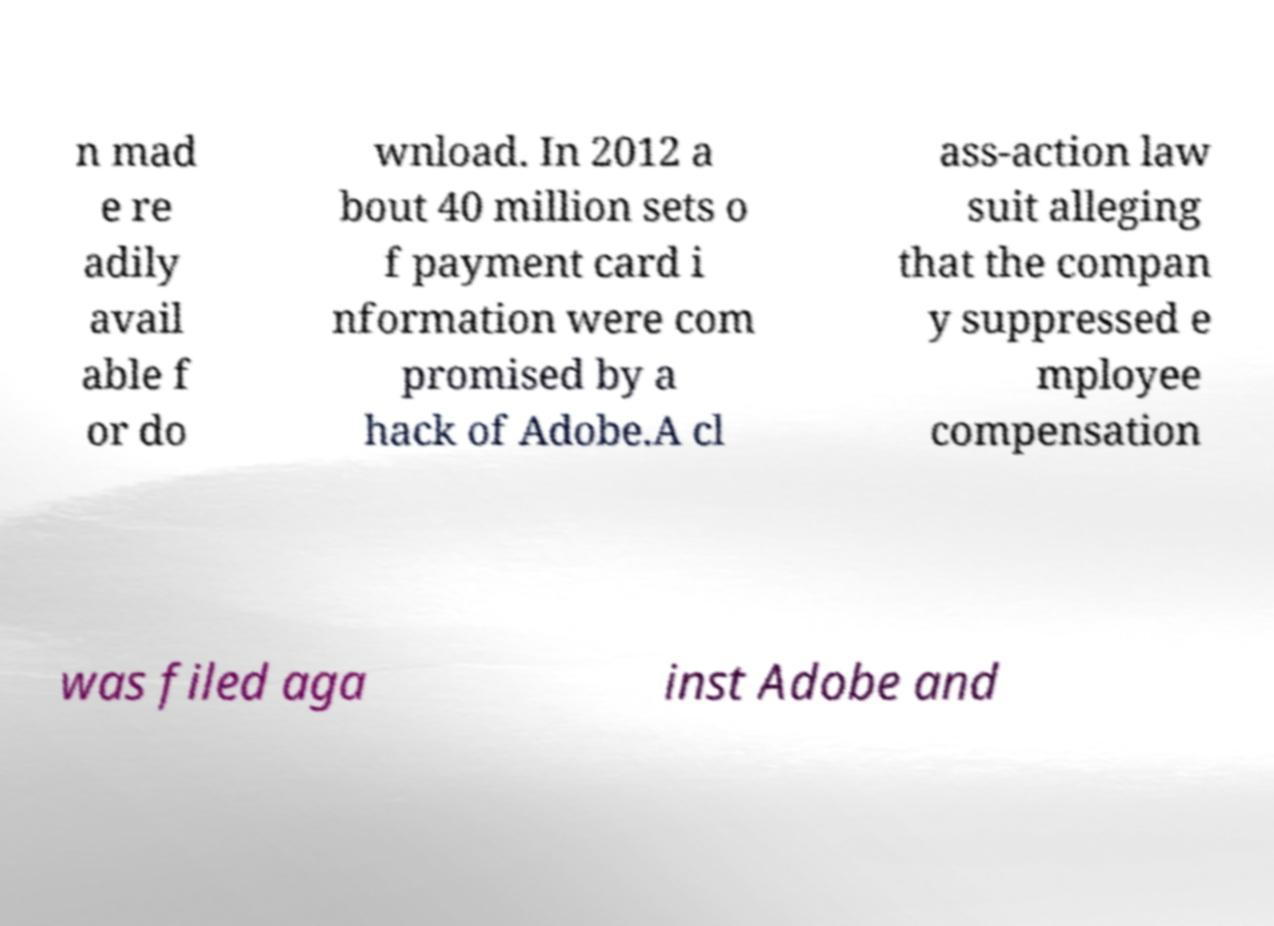Can you accurately transcribe the text from the provided image for me? n mad e re adily avail able f or do wnload. In 2012 a bout 40 million sets o f payment card i nformation were com promised by a hack of Adobe.A cl ass-action law suit alleging that the compan y suppressed e mployee compensation was filed aga inst Adobe and 